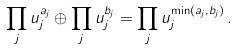Convert formula to latex. <formula><loc_0><loc_0><loc_500><loc_500>\prod _ { j } u _ { j } ^ { a _ { j } } \oplus \prod _ { j } u _ { j } ^ { b _ { j } } = \prod _ { j } u _ { j } ^ { \min ( a _ { j } , b _ { j } ) } \, .</formula> 